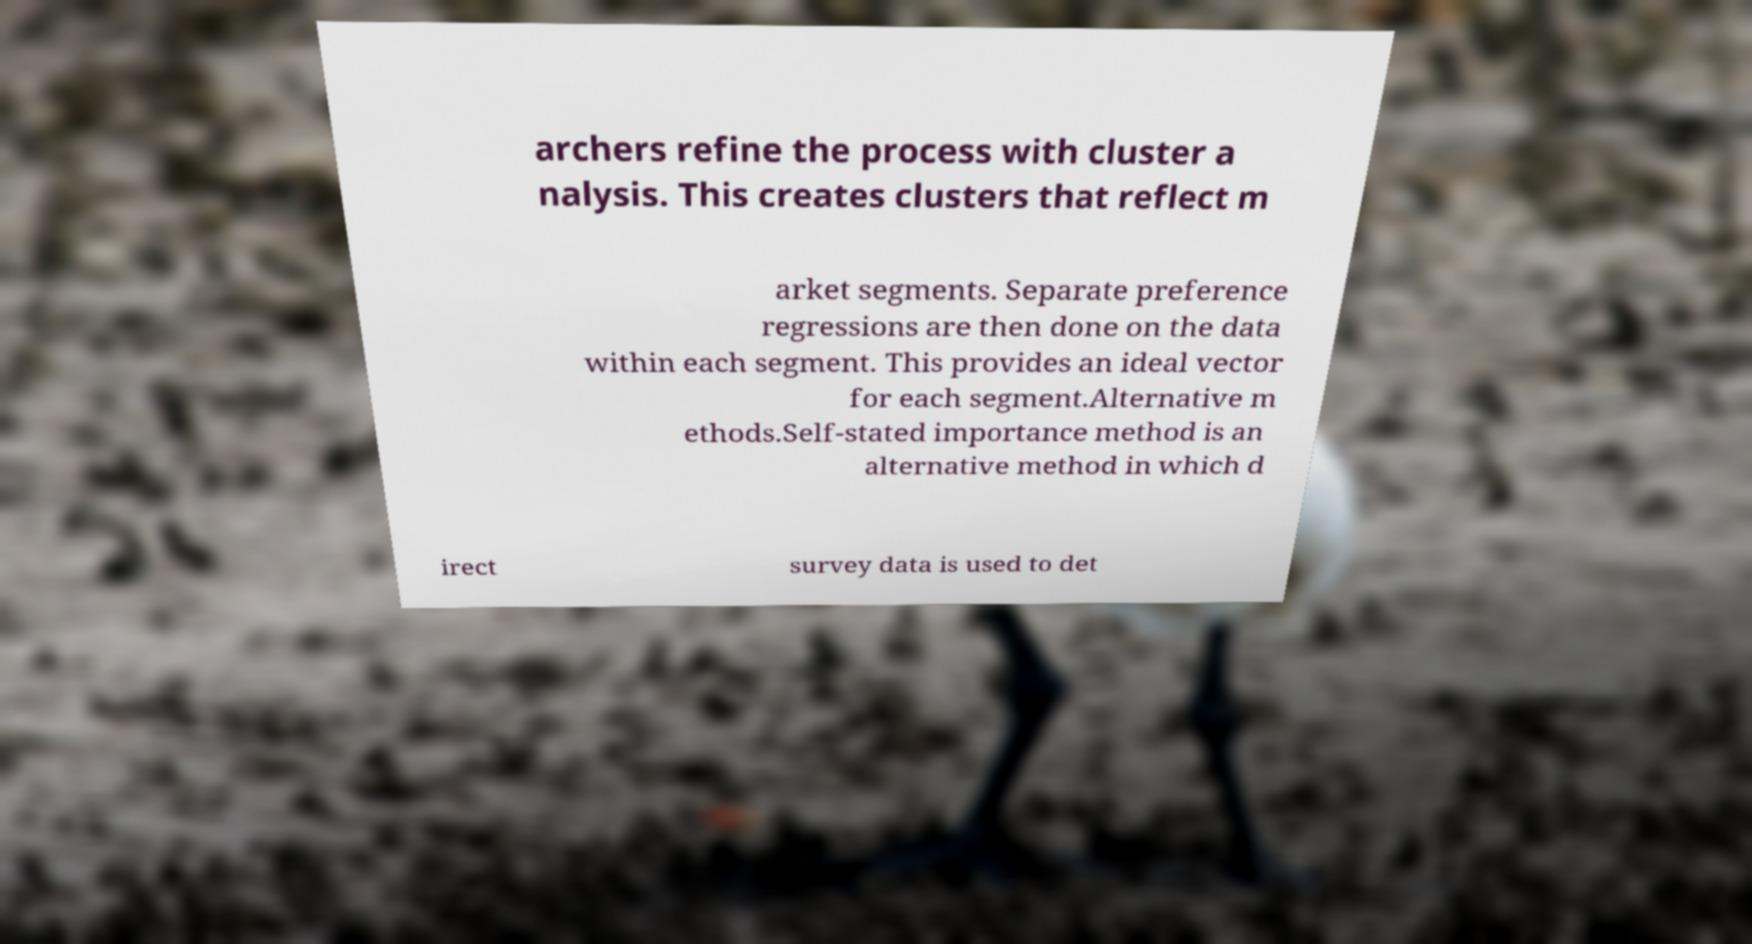Can you read and provide the text displayed in the image?This photo seems to have some interesting text. Can you extract and type it out for me? archers refine the process with cluster a nalysis. This creates clusters that reflect m arket segments. Separate preference regressions are then done on the data within each segment. This provides an ideal vector for each segment.Alternative m ethods.Self-stated importance method is an alternative method in which d irect survey data is used to det 